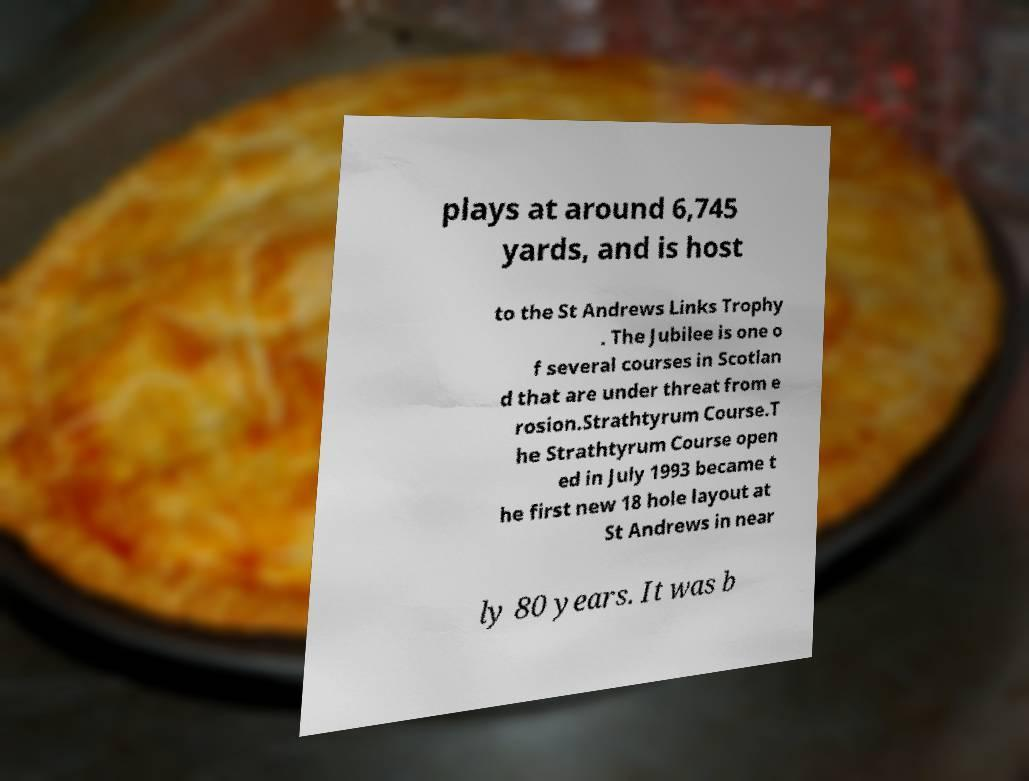Could you assist in decoding the text presented in this image and type it out clearly? plays at around 6,745 yards, and is host to the St Andrews Links Trophy . The Jubilee is one o f several courses in Scotlan d that are under threat from e rosion.Strathtyrum Course.T he Strathtyrum Course open ed in July 1993 became t he first new 18 hole layout at St Andrews in near ly 80 years. It was b 